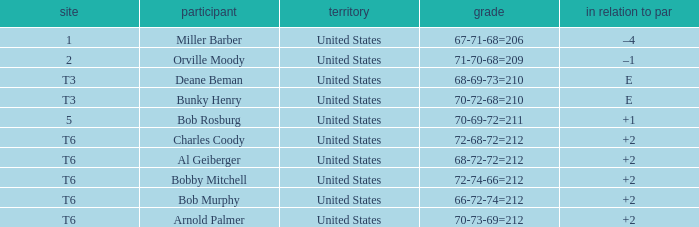What is the to par of player bunky henry? E. 